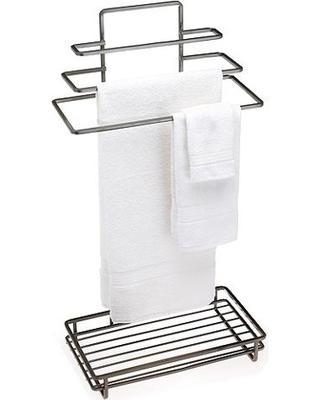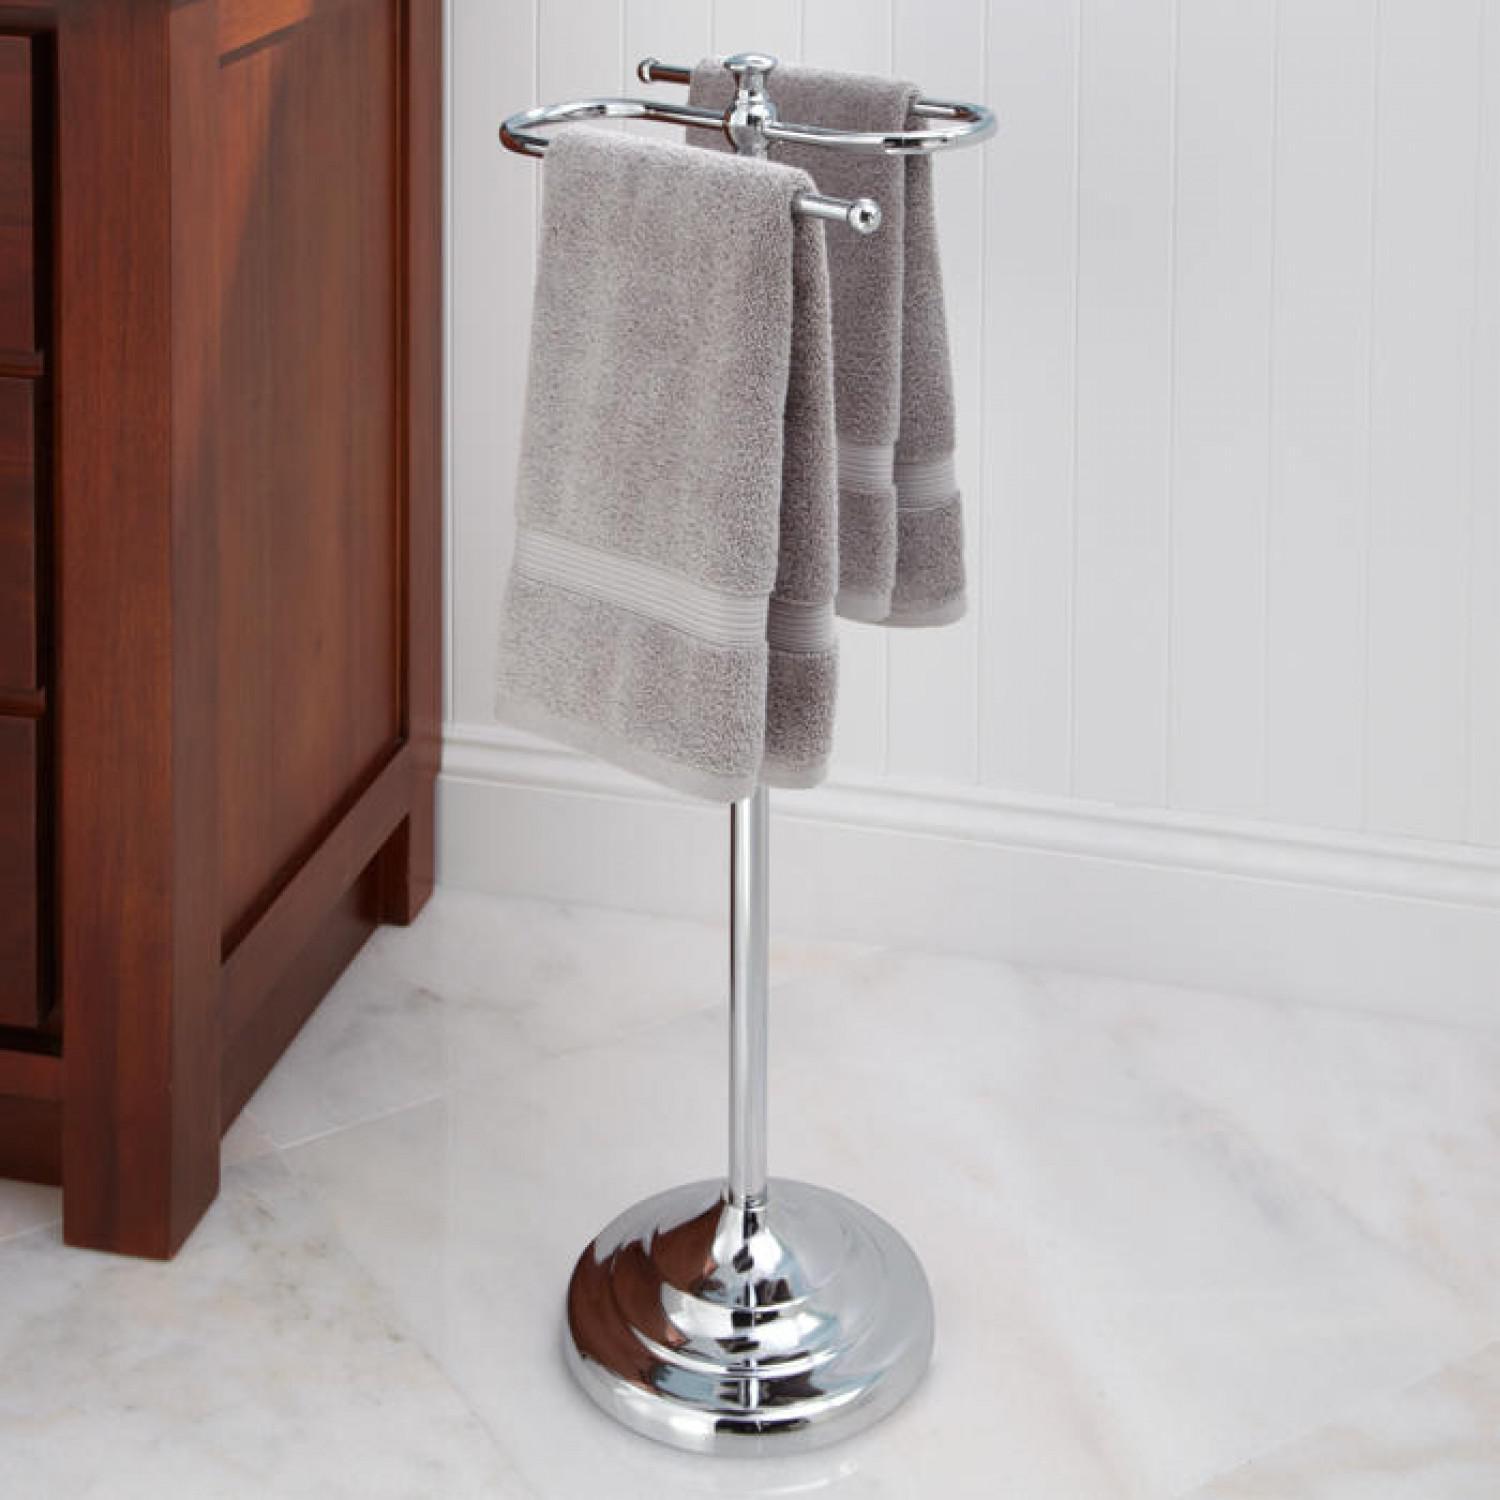The first image is the image on the left, the second image is the image on the right. Analyze the images presented: Is the assertion "dark colored towels are layers in 3's on a chrome stand" valid? Answer yes or no. No. The first image is the image on the left, the second image is the image on the right. Evaluate the accuracy of this statement regarding the images: "One set of towels is plain, and the other has a pattern on at least a portion of it.". Is it true? Answer yes or no. No. 